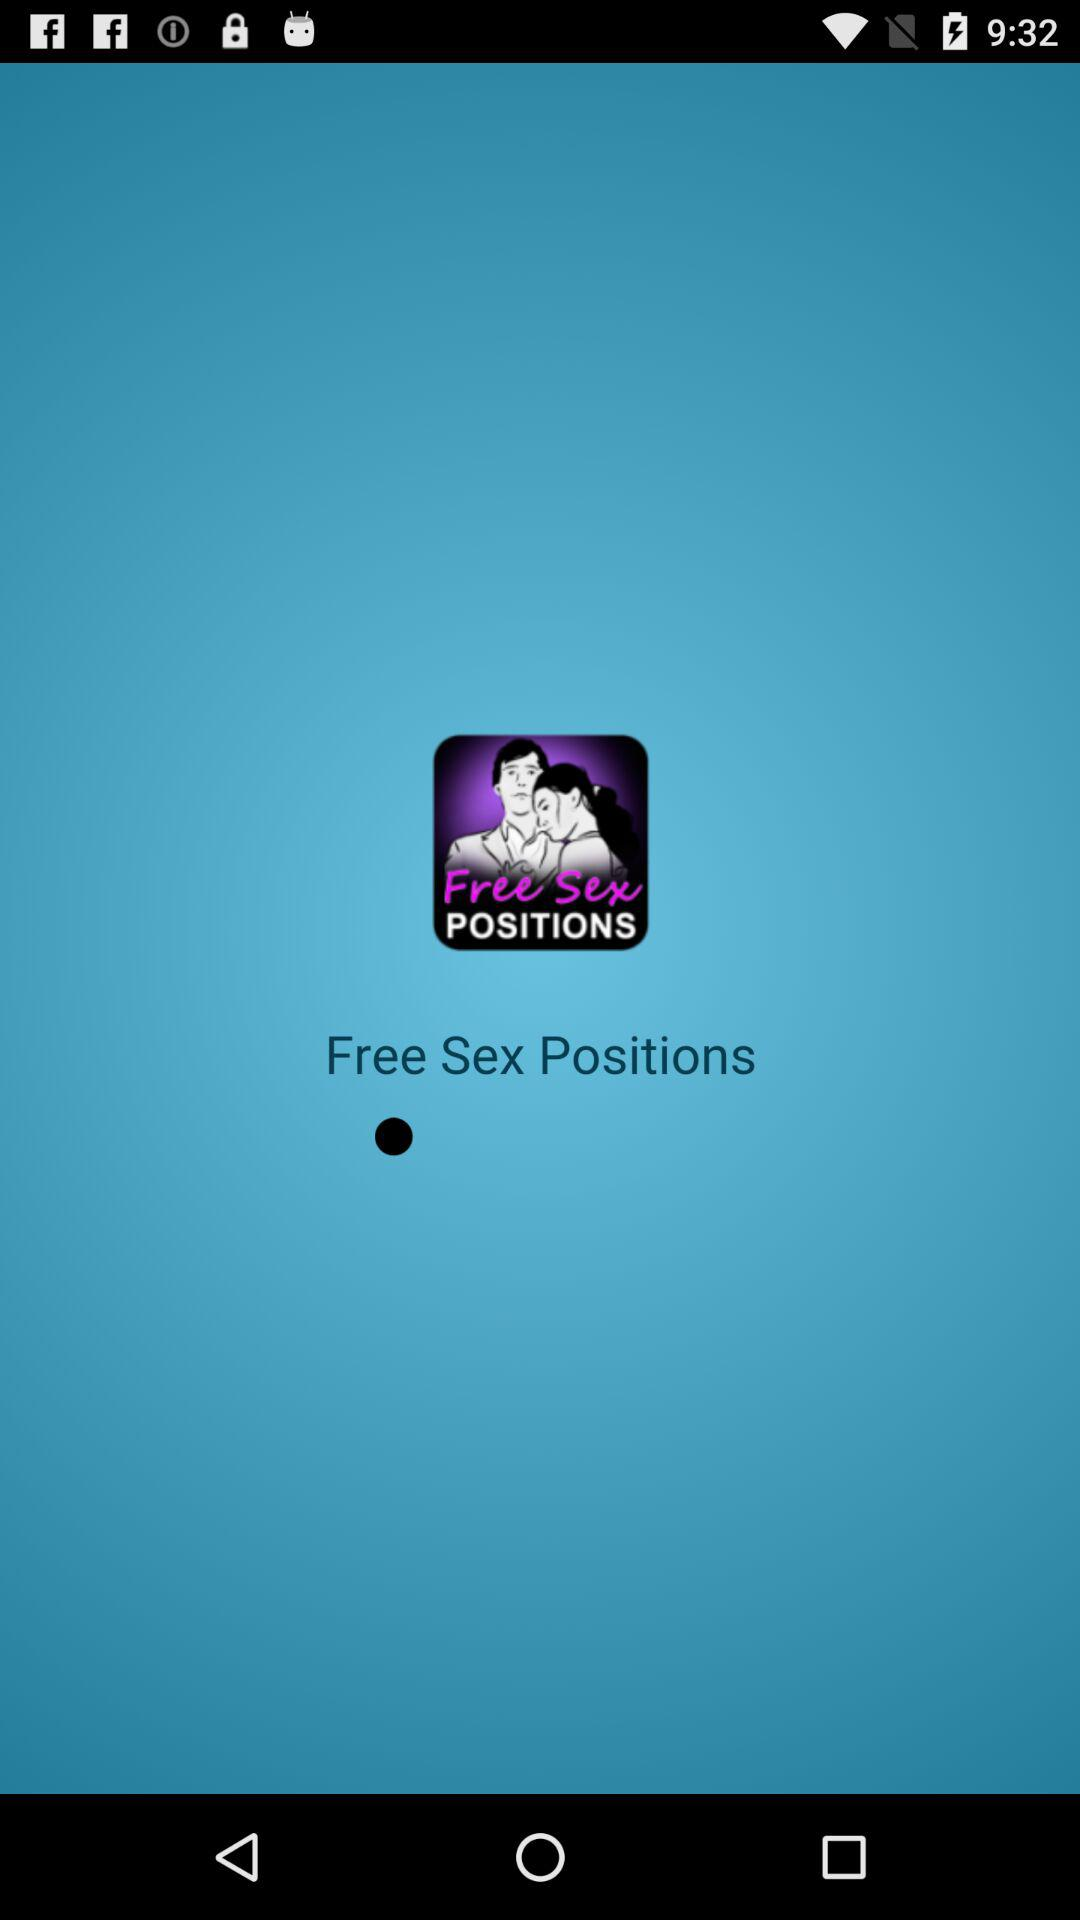How many sex positions are available?
When the provided information is insufficient, respond with <no answer>. <no answer> 